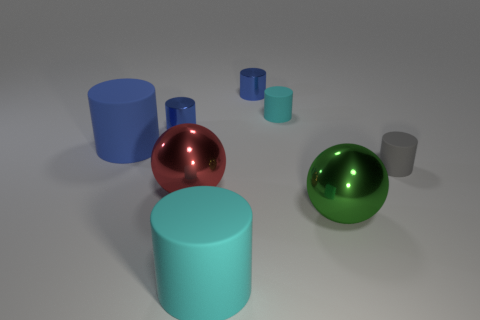How many blue cylinders must be subtracted to get 1 blue cylinders? 2 Subtract all gray blocks. How many blue cylinders are left? 3 Subtract all gray cylinders. How many cylinders are left? 5 Subtract all small shiny cylinders. How many cylinders are left? 4 Subtract all cyan cylinders. Subtract all purple cubes. How many cylinders are left? 4 Add 1 small cyan things. How many objects exist? 9 Subtract all cylinders. How many objects are left? 2 Subtract 3 blue cylinders. How many objects are left? 5 Subtract all small gray cylinders. Subtract all blue matte things. How many objects are left? 6 Add 3 big cyan things. How many big cyan things are left? 4 